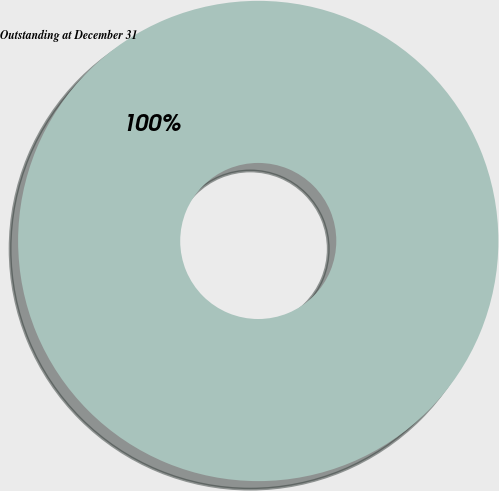<chart> <loc_0><loc_0><loc_500><loc_500><pie_chart><fcel>Outstanding at December 31<nl><fcel>100.0%<nl></chart> 